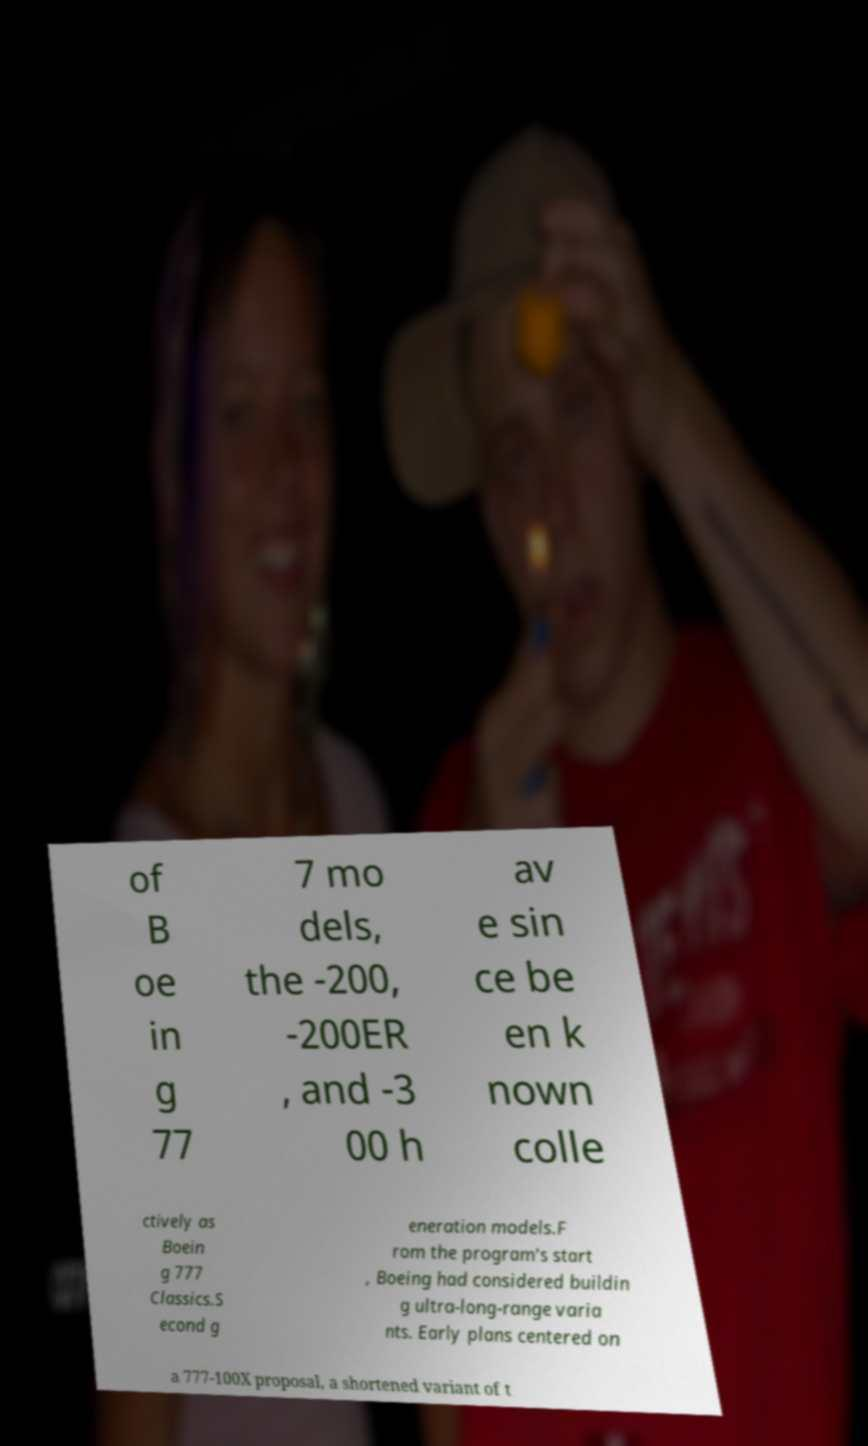There's text embedded in this image that I need extracted. Can you transcribe it verbatim? of B oe in g 77 7 mo dels, the -200, -200ER , and -3 00 h av e sin ce be en k nown colle ctively as Boein g 777 Classics.S econd g eneration models.F rom the program's start , Boeing had considered buildin g ultra-long-range varia nts. Early plans centered on a 777-100X proposal, a shortened variant of t 